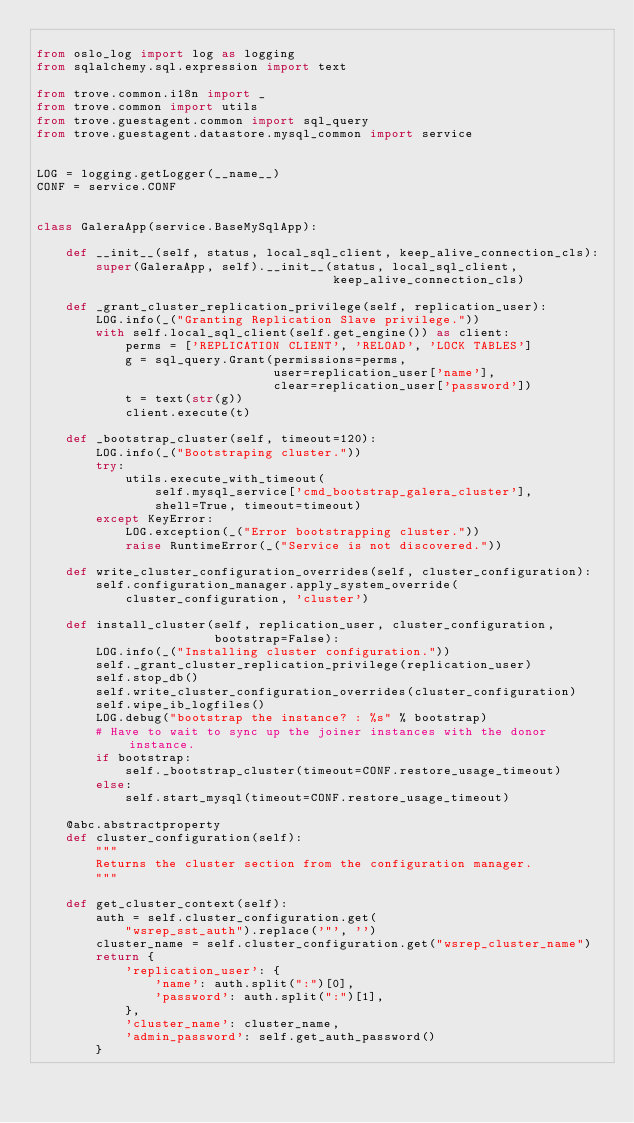Convert code to text. <code><loc_0><loc_0><loc_500><loc_500><_Python_>
from oslo_log import log as logging
from sqlalchemy.sql.expression import text

from trove.common.i18n import _
from trove.common import utils
from trove.guestagent.common import sql_query
from trove.guestagent.datastore.mysql_common import service


LOG = logging.getLogger(__name__)
CONF = service.CONF


class GaleraApp(service.BaseMySqlApp):

    def __init__(self, status, local_sql_client, keep_alive_connection_cls):
        super(GaleraApp, self).__init__(status, local_sql_client,
                                        keep_alive_connection_cls)

    def _grant_cluster_replication_privilege(self, replication_user):
        LOG.info(_("Granting Replication Slave privilege."))
        with self.local_sql_client(self.get_engine()) as client:
            perms = ['REPLICATION CLIENT', 'RELOAD', 'LOCK TABLES']
            g = sql_query.Grant(permissions=perms,
                                user=replication_user['name'],
                                clear=replication_user['password'])
            t = text(str(g))
            client.execute(t)

    def _bootstrap_cluster(self, timeout=120):
        LOG.info(_("Bootstraping cluster."))
        try:
            utils.execute_with_timeout(
                self.mysql_service['cmd_bootstrap_galera_cluster'],
                shell=True, timeout=timeout)
        except KeyError:
            LOG.exception(_("Error bootstrapping cluster."))
            raise RuntimeError(_("Service is not discovered."))

    def write_cluster_configuration_overrides(self, cluster_configuration):
        self.configuration_manager.apply_system_override(
            cluster_configuration, 'cluster')

    def install_cluster(self, replication_user, cluster_configuration,
                        bootstrap=False):
        LOG.info(_("Installing cluster configuration."))
        self._grant_cluster_replication_privilege(replication_user)
        self.stop_db()
        self.write_cluster_configuration_overrides(cluster_configuration)
        self.wipe_ib_logfiles()
        LOG.debug("bootstrap the instance? : %s" % bootstrap)
        # Have to wait to sync up the joiner instances with the donor instance.
        if bootstrap:
            self._bootstrap_cluster(timeout=CONF.restore_usage_timeout)
        else:
            self.start_mysql(timeout=CONF.restore_usage_timeout)

    @abc.abstractproperty
    def cluster_configuration(self):
        """
        Returns the cluster section from the configuration manager.
        """

    def get_cluster_context(self):
        auth = self.cluster_configuration.get(
            "wsrep_sst_auth").replace('"', '')
        cluster_name = self.cluster_configuration.get("wsrep_cluster_name")
        return {
            'replication_user': {
                'name': auth.split(":")[0],
                'password': auth.split(":")[1],
            },
            'cluster_name': cluster_name,
            'admin_password': self.get_auth_password()
        }
</code> 